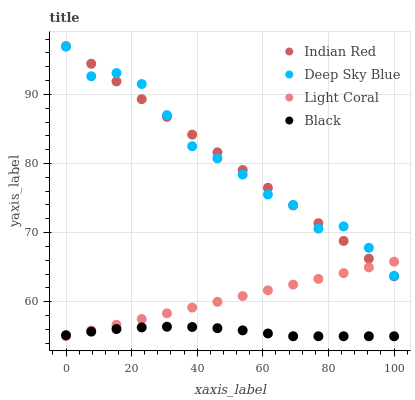Does Black have the minimum area under the curve?
Answer yes or no. Yes. Does Deep Sky Blue have the maximum area under the curve?
Answer yes or no. Yes. Does Deep Sky Blue have the minimum area under the curve?
Answer yes or no. No. Does Black have the maximum area under the curve?
Answer yes or no. No. Is Light Coral the smoothest?
Answer yes or no. Yes. Is Deep Sky Blue the roughest?
Answer yes or no. Yes. Is Black the smoothest?
Answer yes or no. No. Is Black the roughest?
Answer yes or no. No. Does Light Coral have the lowest value?
Answer yes or no. Yes. Does Deep Sky Blue have the lowest value?
Answer yes or no. No. Does Indian Red have the highest value?
Answer yes or no. Yes. Does Deep Sky Blue have the highest value?
Answer yes or no. No. Is Black less than Indian Red?
Answer yes or no. Yes. Is Indian Red greater than Black?
Answer yes or no. Yes. Does Black intersect Light Coral?
Answer yes or no. Yes. Is Black less than Light Coral?
Answer yes or no. No. Is Black greater than Light Coral?
Answer yes or no. No. Does Black intersect Indian Red?
Answer yes or no. No. 